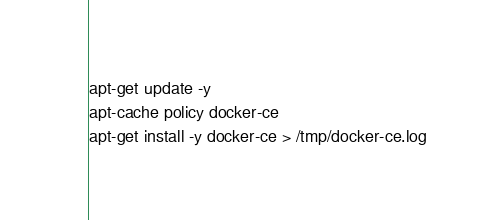<code> <loc_0><loc_0><loc_500><loc_500><_Bash_>apt-get update -y
apt-cache policy docker-ce
apt-get install -y docker-ce > /tmp/docker-ce.log
</code> 